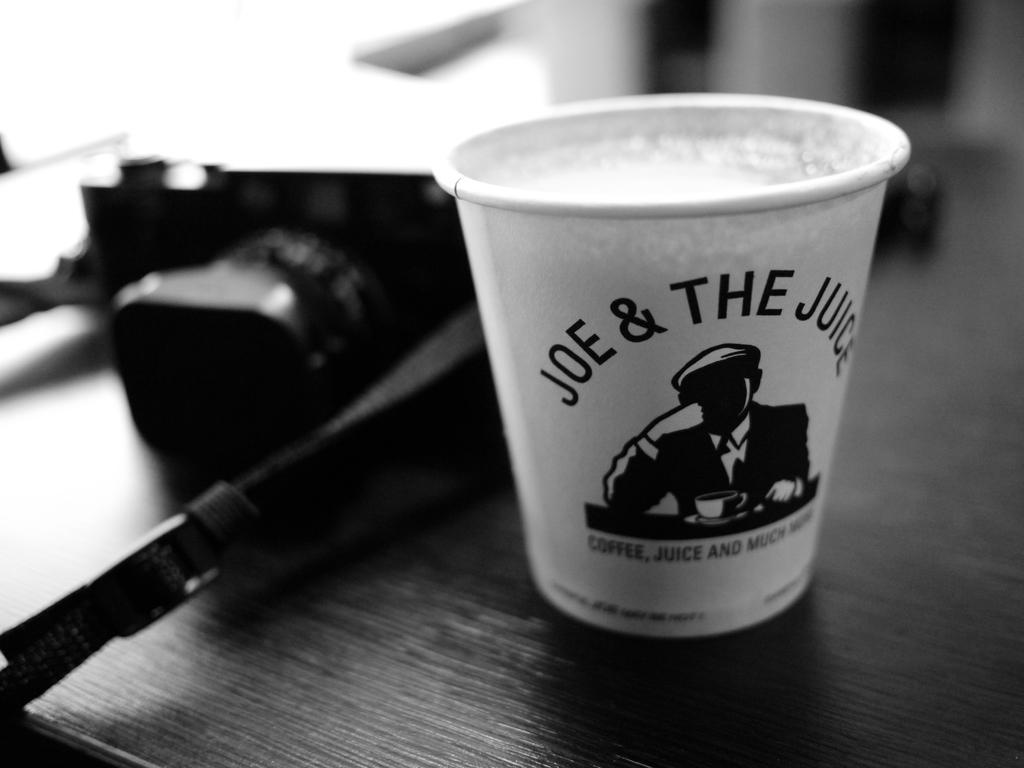What does it say on the paper cup?
Your answer should be compact. Joe & the juice. What is the name on the cup?
Your answer should be very brief. Joe. 